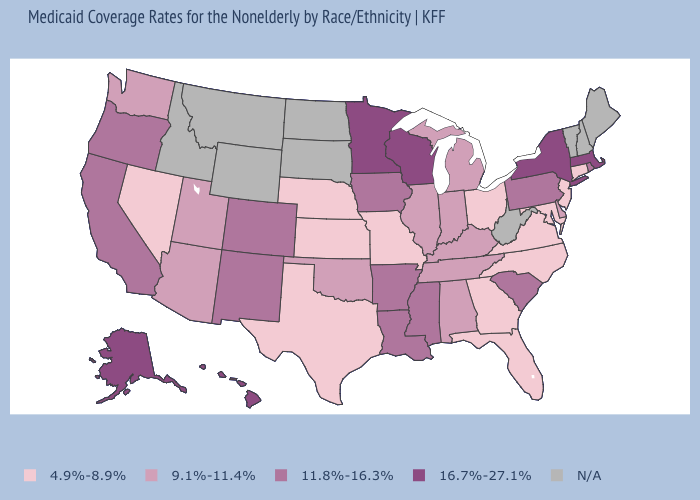What is the lowest value in the South?
Write a very short answer. 4.9%-8.9%. What is the value of Virginia?
Give a very brief answer. 4.9%-8.9%. Does Missouri have the lowest value in the USA?
Be succinct. Yes. Does New York have the highest value in the USA?
Give a very brief answer. Yes. Among the states that border Texas , does Louisiana have the lowest value?
Answer briefly. No. Name the states that have a value in the range 9.1%-11.4%?
Concise answer only. Alabama, Arizona, Delaware, Illinois, Indiana, Kentucky, Michigan, Oklahoma, Tennessee, Utah, Washington. Does New Jersey have the highest value in the USA?
Short answer required. No. What is the lowest value in the USA?
Short answer required. 4.9%-8.9%. Which states have the lowest value in the USA?
Be succinct. Connecticut, Florida, Georgia, Kansas, Maryland, Missouri, Nebraska, Nevada, New Jersey, North Carolina, Ohio, Texas, Virginia. What is the highest value in the USA?
Answer briefly. 16.7%-27.1%. Which states hav the highest value in the MidWest?
Give a very brief answer. Minnesota, Wisconsin. Does Utah have the highest value in the USA?
Concise answer only. No. 